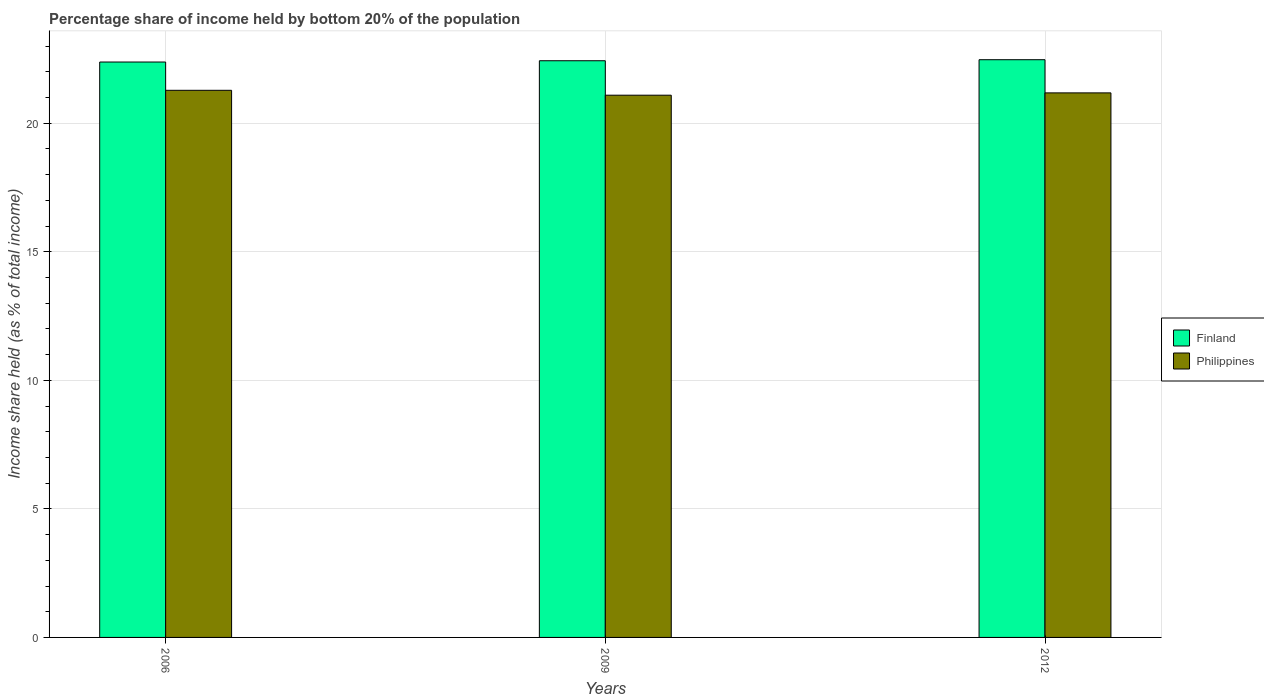How many different coloured bars are there?
Your answer should be compact. 2. How many groups of bars are there?
Your response must be concise. 3. Are the number of bars per tick equal to the number of legend labels?
Your answer should be very brief. Yes. Are the number of bars on each tick of the X-axis equal?
Your answer should be very brief. Yes. How many bars are there on the 1st tick from the left?
Offer a terse response. 2. How many bars are there on the 1st tick from the right?
Your response must be concise. 2. What is the label of the 1st group of bars from the left?
Your answer should be compact. 2006. What is the share of income held by bottom 20% of the population in Philippines in 2006?
Provide a short and direct response. 21.28. Across all years, what is the maximum share of income held by bottom 20% of the population in Philippines?
Give a very brief answer. 21.28. Across all years, what is the minimum share of income held by bottom 20% of the population in Finland?
Provide a succinct answer. 22.38. In which year was the share of income held by bottom 20% of the population in Finland maximum?
Your response must be concise. 2012. What is the total share of income held by bottom 20% of the population in Philippines in the graph?
Offer a terse response. 63.55. What is the difference between the share of income held by bottom 20% of the population in Finland in 2006 and that in 2012?
Provide a short and direct response. -0.09. What is the difference between the share of income held by bottom 20% of the population in Finland in 2009 and the share of income held by bottom 20% of the population in Philippines in 2006?
Your answer should be very brief. 1.15. What is the average share of income held by bottom 20% of the population in Philippines per year?
Your answer should be very brief. 21.18. In the year 2012, what is the difference between the share of income held by bottom 20% of the population in Philippines and share of income held by bottom 20% of the population in Finland?
Offer a very short reply. -1.29. In how many years, is the share of income held by bottom 20% of the population in Philippines greater than 20 %?
Provide a short and direct response. 3. What is the ratio of the share of income held by bottom 20% of the population in Philippines in 2006 to that in 2009?
Your answer should be compact. 1.01. Is the share of income held by bottom 20% of the population in Philippines in 2006 less than that in 2012?
Your answer should be compact. No. Is the difference between the share of income held by bottom 20% of the population in Philippines in 2006 and 2009 greater than the difference between the share of income held by bottom 20% of the population in Finland in 2006 and 2009?
Provide a succinct answer. Yes. What is the difference between the highest and the second highest share of income held by bottom 20% of the population in Finland?
Your answer should be very brief. 0.04. What is the difference between the highest and the lowest share of income held by bottom 20% of the population in Finland?
Offer a terse response. 0.09. Is the sum of the share of income held by bottom 20% of the population in Finland in 2009 and 2012 greater than the maximum share of income held by bottom 20% of the population in Philippines across all years?
Your answer should be very brief. Yes. Are all the bars in the graph horizontal?
Your response must be concise. No. Does the graph contain any zero values?
Offer a very short reply. No. Where does the legend appear in the graph?
Give a very brief answer. Center right. How many legend labels are there?
Provide a succinct answer. 2. How are the legend labels stacked?
Your response must be concise. Vertical. What is the title of the graph?
Your answer should be very brief. Percentage share of income held by bottom 20% of the population. What is the label or title of the X-axis?
Your response must be concise. Years. What is the label or title of the Y-axis?
Your response must be concise. Income share held (as % of total income). What is the Income share held (as % of total income) in Finland in 2006?
Provide a short and direct response. 22.38. What is the Income share held (as % of total income) of Philippines in 2006?
Provide a short and direct response. 21.28. What is the Income share held (as % of total income) in Finland in 2009?
Your response must be concise. 22.43. What is the Income share held (as % of total income) of Philippines in 2009?
Keep it short and to the point. 21.09. What is the Income share held (as % of total income) of Finland in 2012?
Keep it short and to the point. 22.47. What is the Income share held (as % of total income) of Philippines in 2012?
Your answer should be compact. 21.18. Across all years, what is the maximum Income share held (as % of total income) of Finland?
Ensure brevity in your answer.  22.47. Across all years, what is the maximum Income share held (as % of total income) of Philippines?
Your answer should be very brief. 21.28. Across all years, what is the minimum Income share held (as % of total income) of Finland?
Provide a short and direct response. 22.38. Across all years, what is the minimum Income share held (as % of total income) in Philippines?
Offer a very short reply. 21.09. What is the total Income share held (as % of total income) of Finland in the graph?
Give a very brief answer. 67.28. What is the total Income share held (as % of total income) in Philippines in the graph?
Your response must be concise. 63.55. What is the difference between the Income share held (as % of total income) in Philippines in 2006 and that in 2009?
Your answer should be compact. 0.19. What is the difference between the Income share held (as % of total income) of Finland in 2006 and that in 2012?
Make the answer very short. -0.09. What is the difference between the Income share held (as % of total income) in Finland in 2009 and that in 2012?
Provide a succinct answer. -0.04. What is the difference between the Income share held (as % of total income) in Philippines in 2009 and that in 2012?
Offer a terse response. -0.09. What is the difference between the Income share held (as % of total income) of Finland in 2006 and the Income share held (as % of total income) of Philippines in 2009?
Ensure brevity in your answer.  1.29. What is the difference between the Income share held (as % of total income) of Finland in 2006 and the Income share held (as % of total income) of Philippines in 2012?
Your answer should be compact. 1.2. What is the average Income share held (as % of total income) in Finland per year?
Keep it short and to the point. 22.43. What is the average Income share held (as % of total income) in Philippines per year?
Your answer should be very brief. 21.18. In the year 2006, what is the difference between the Income share held (as % of total income) in Finland and Income share held (as % of total income) in Philippines?
Your answer should be very brief. 1.1. In the year 2009, what is the difference between the Income share held (as % of total income) of Finland and Income share held (as % of total income) of Philippines?
Provide a short and direct response. 1.34. In the year 2012, what is the difference between the Income share held (as % of total income) in Finland and Income share held (as % of total income) in Philippines?
Ensure brevity in your answer.  1.29. What is the ratio of the Income share held (as % of total income) of Finland in 2006 to that in 2009?
Make the answer very short. 1. What is the ratio of the Income share held (as % of total income) of Finland in 2006 to that in 2012?
Keep it short and to the point. 1. What is the ratio of the Income share held (as % of total income) of Finland in 2009 to that in 2012?
Your response must be concise. 1. What is the difference between the highest and the lowest Income share held (as % of total income) of Finland?
Offer a very short reply. 0.09. What is the difference between the highest and the lowest Income share held (as % of total income) in Philippines?
Provide a succinct answer. 0.19. 